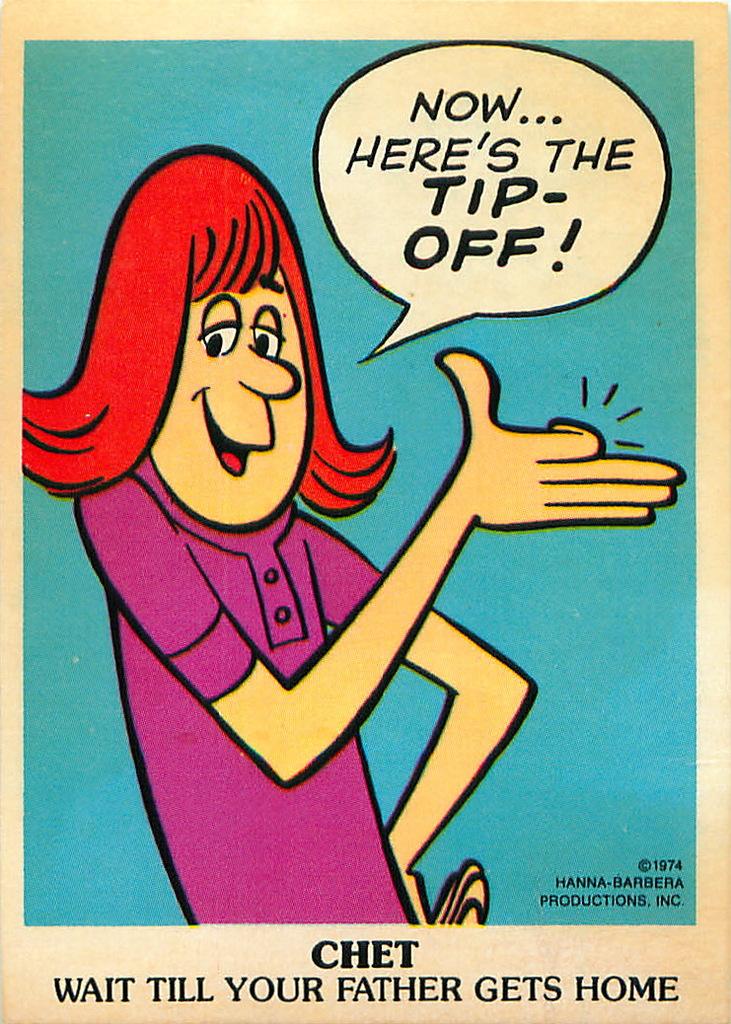What is the name of this cartoon?
Your answer should be very brief. Chet. What are they saying?
Keep it short and to the point. Now... here's the tip-off!. 